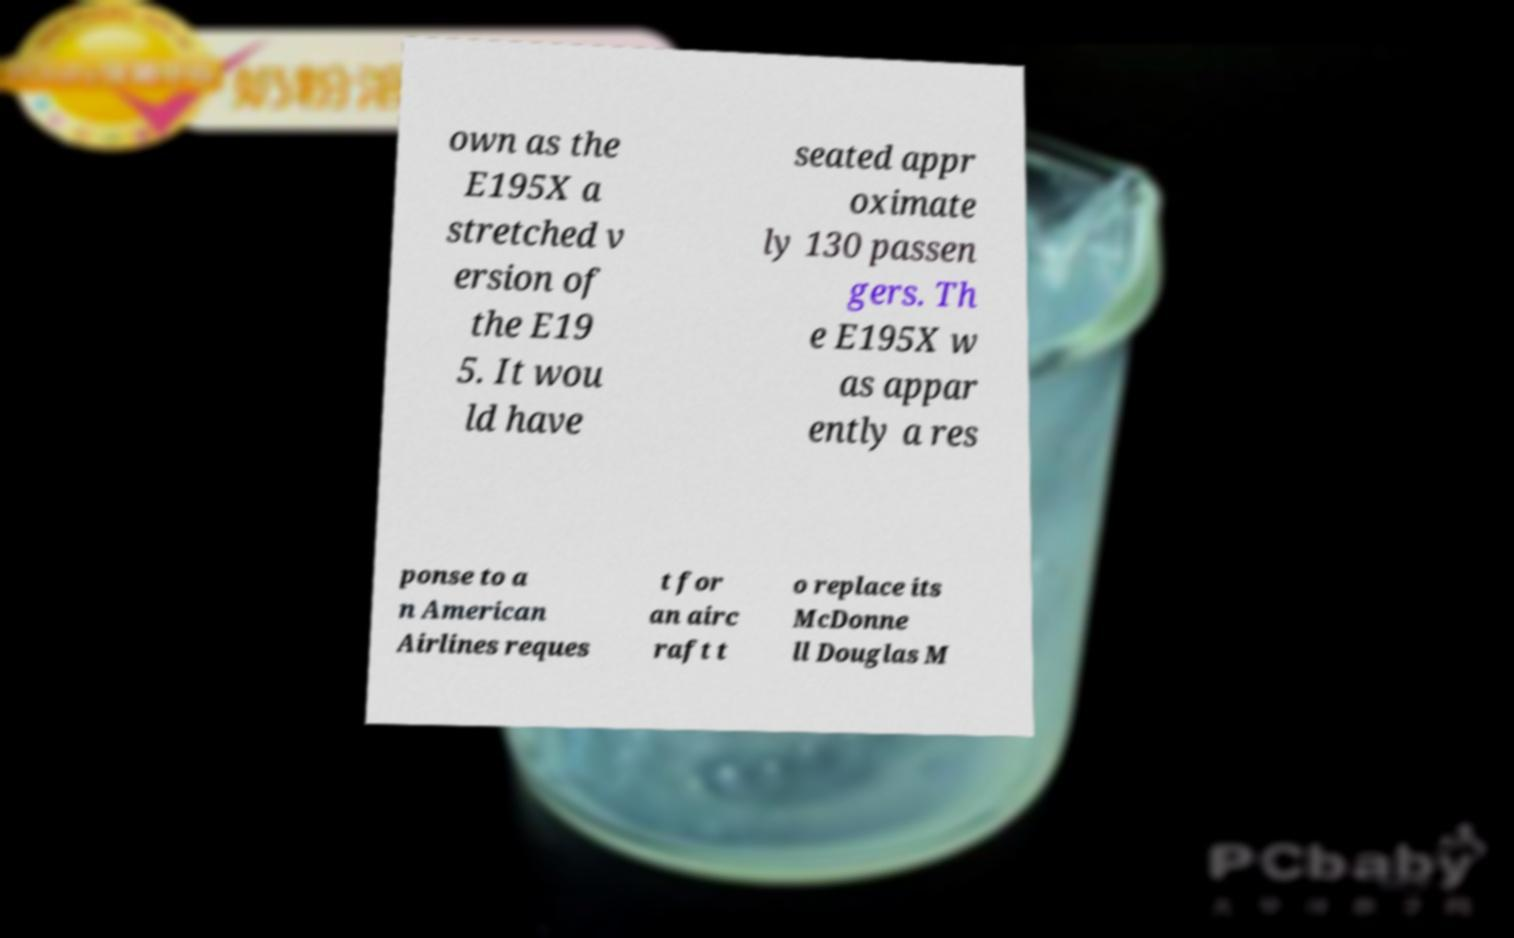For documentation purposes, I need the text within this image transcribed. Could you provide that? own as the E195X a stretched v ersion of the E19 5. It wou ld have seated appr oximate ly 130 passen gers. Th e E195X w as appar ently a res ponse to a n American Airlines reques t for an airc raft t o replace its McDonne ll Douglas M 